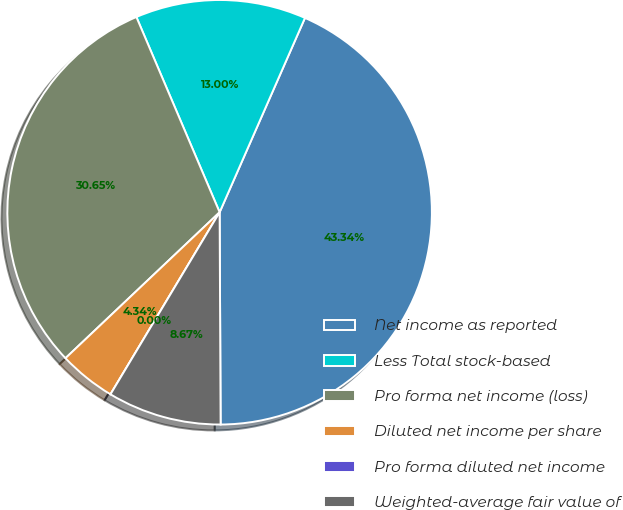Convert chart to OTSL. <chart><loc_0><loc_0><loc_500><loc_500><pie_chart><fcel>Net income as reported<fcel>Less Total stock-based<fcel>Pro forma net income (loss)<fcel>Diluted net income per share<fcel>Pro forma diluted net income<fcel>Weighted-average fair value of<nl><fcel>43.34%<fcel>13.0%<fcel>30.65%<fcel>4.34%<fcel>0.0%<fcel>8.67%<nl></chart> 